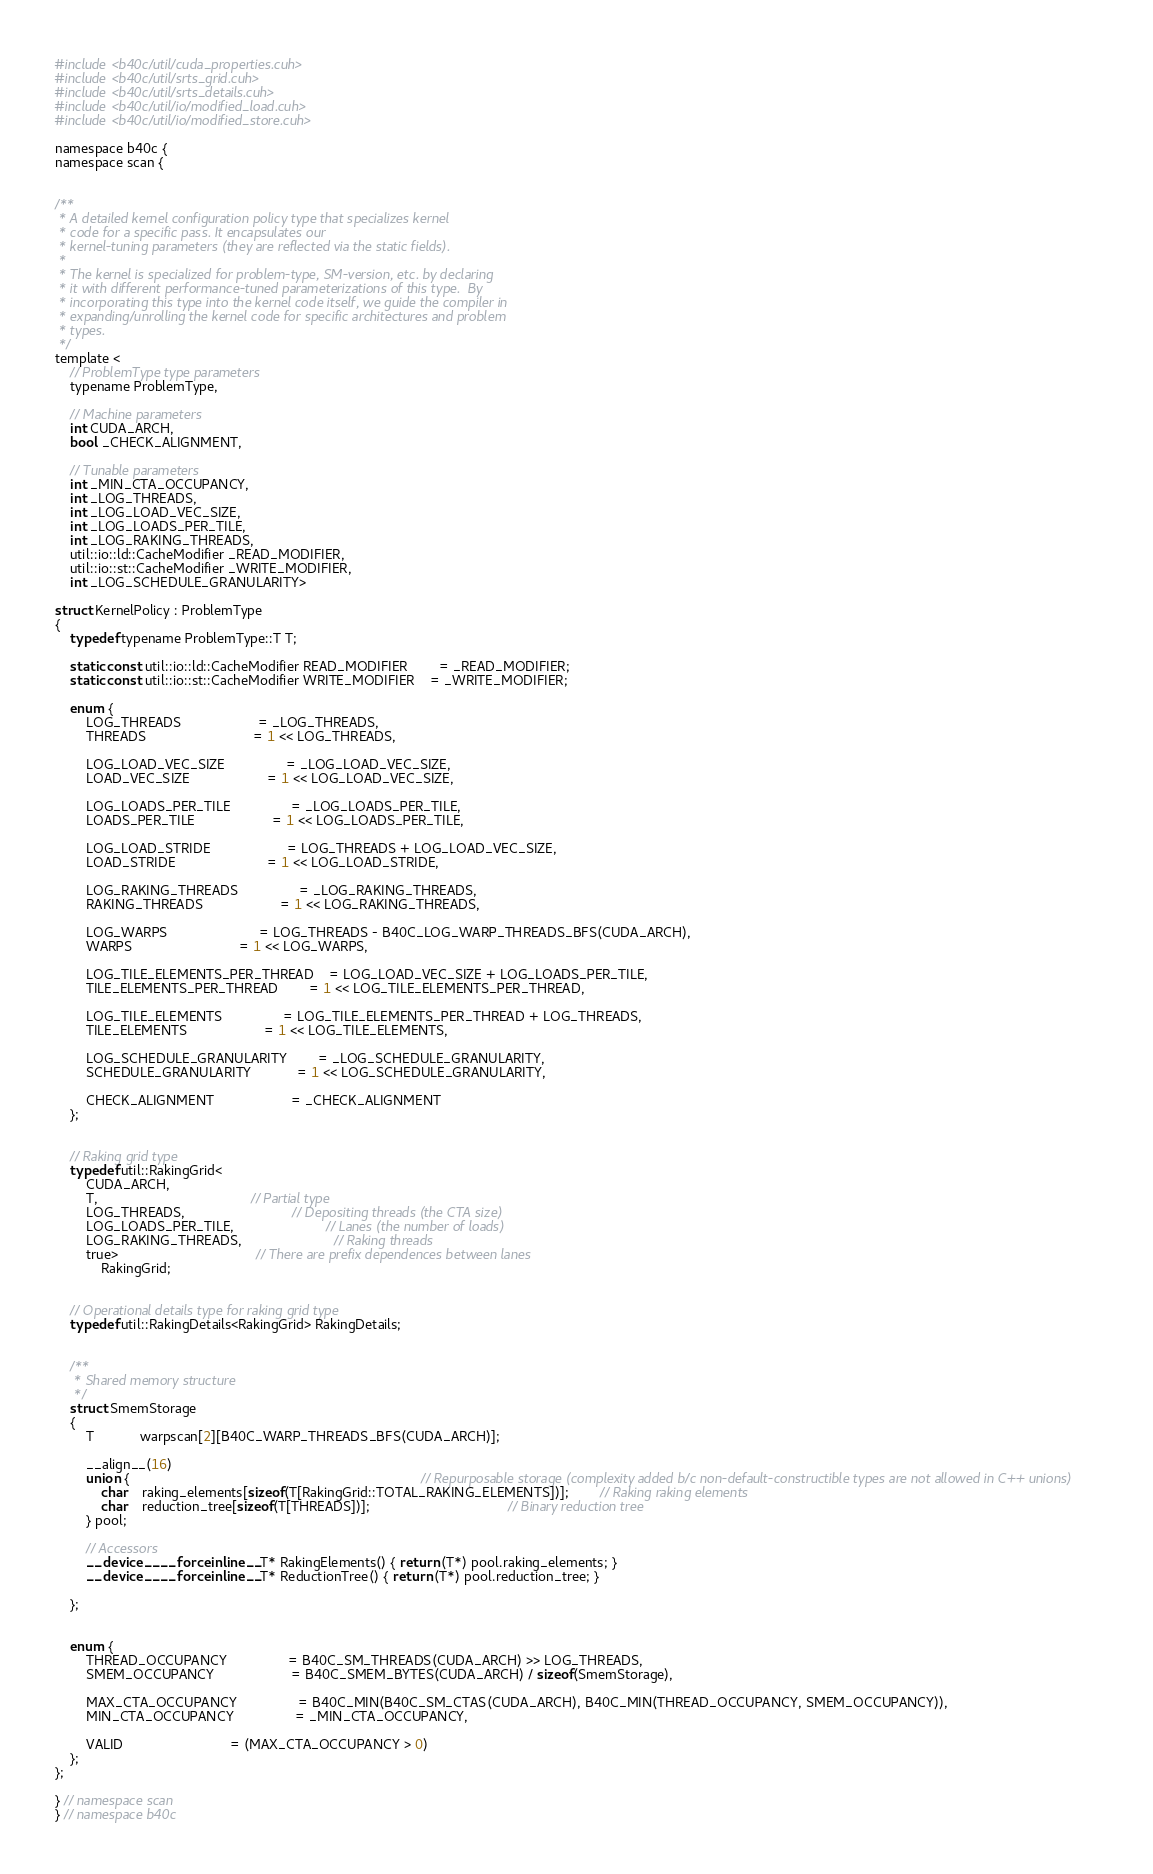<code> <loc_0><loc_0><loc_500><loc_500><_Cuda_>#include <b40c/util/cuda_properties.cuh>
#include <b40c/util/srts_grid.cuh>
#include <b40c/util/srts_details.cuh>
#include <b40c/util/io/modified_load.cuh>
#include <b40c/util/io/modified_store.cuh>

namespace b40c {
namespace scan {


/**
 * A detailed kernel configuration policy type that specializes kernel
 * code for a specific pass. It encapsulates our
 * kernel-tuning parameters (they are reflected via the static fields).
 *
 * The kernel is specialized for problem-type, SM-version, etc. by declaring
 * it with different performance-tuned parameterizations of this type.  By
 * incorporating this type into the kernel code itself, we guide the compiler in
 * expanding/unrolling the kernel code for specific architectures and problem
 * types.
 */
template <
	// ProblemType type parameters
	typename ProblemType,

	// Machine parameters
	int CUDA_ARCH,
	bool _CHECK_ALIGNMENT,

	// Tunable parameters
	int _MIN_CTA_OCCUPANCY,
	int _LOG_THREADS,
	int _LOG_LOAD_VEC_SIZE,
	int _LOG_LOADS_PER_TILE,
	int _LOG_RAKING_THREADS,
	util::io::ld::CacheModifier _READ_MODIFIER,
	util::io::st::CacheModifier _WRITE_MODIFIER,
	int _LOG_SCHEDULE_GRANULARITY>

struct KernelPolicy : ProblemType
{
	typedef typename ProblemType::T T;

	static const util::io::ld::CacheModifier READ_MODIFIER 		= _READ_MODIFIER;
	static const util::io::st::CacheModifier WRITE_MODIFIER 	= _WRITE_MODIFIER;

	enum {
		LOG_THREADS 					= _LOG_THREADS,
		THREADS							= 1 << LOG_THREADS,

		LOG_LOAD_VEC_SIZE  				= _LOG_LOAD_VEC_SIZE,
		LOAD_VEC_SIZE					= 1 << LOG_LOAD_VEC_SIZE,

		LOG_LOADS_PER_TILE 				= _LOG_LOADS_PER_TILE,
		LOADS_PER_TILE					= 1 << LOG_LOADS_PER_TILE,

		LOG_LOAD_STRIDE					= LOG_THREADS + LOG_LOAD_VEC_SIZE,
		LOAD_STRIDE						= 1 << LOG_LOAD_STRIDE,

		LOG_RAKING_THREADS				= _LOG_RAKING_THREADS,
		RAKING_THREADS					= 1 << LOG_RAKING_THREADS,

		LOG_WARPS						= LOG_THREADS - B40C_LOG_WARP_THREADS_BFS(CUDA_ARCH),
		WARPS							= 1 << LOG_WARPS,

		LOG_TILE_ELEMENTS_PER_THREAD	= LOG_LOAD_VEC_SIZE + LOG_LOADS_PER_TILE,
		TILE_ELEMENTS_PER_THREAD		= 1 << LOG_TILE_ELEMENTS_PER_THREAD,

		LOG_TILE_ELEMENTS 				= LOG_TILE_ELEMENTS_PER_THREAD + LOG_THREADS,
		TILE_ELEMENTS					= 1 << LOG_TILE_ELEMENTS,

		LOG_SCHEDULE_GRANULARITY		= _LOG_SCHEDULE_GRANULARITY,
		SCHEDULE_GRANULARITY			= 1 << LOG_SCHEDULE_GRANULARITY,

		CHECK_ALIGNMENT					= _CHECK_ALIGNMENT
	};


	// Raking grid type
	typedef util::RakingGrid<
		CUDA_ARCH,
		T,										// Partial type
		LOG_THREADS,							// Depositing threads (the CTA size)
		LOG_LOADS_PER_TILE,						// Lanes (the number of loads)
		LOG_RAKING_THREADS,						// Raking threads
		true>									// There are prefix dependences between lanes
			RakingGrid;


	// Operational details type for raking grid type
	typedef util::RakingDetails<RakingGrid> RakingDetails;


	/**
	 * Shared memory structure
	 */
	struct SmemStorage
	{
		T 			warpscan[2][B40C_WARP_THREADS_BFS(CUDA_ARCH)];

		__align__(16)
		union {																			// Repurposable storage (complexity added b/c non-default-constructible types are not allowed in C++ unions)
			char	raking_elements[sizeof(T[RakingGrid::TOTAL_RAKING_ELEMENTS])];		// Raking raking elements
			char	reduction_tree[sizeof(T[THREADS])];									// Binary reduction tree
		} pool;

		// Accessors
		__device__ __forceinline__ T* RakingElements() { return (T*) pool.raking_elements; }
		__device__ __forceinline__ T* ReductionTree() { return (T*) pool.reduction_tree; }

	};


	enum {
		THREAD_OCCUPANCY				= B40C_SM_THREADS(CUDA_ARCH) >> LOG_THREADS,
		SMEM_OCCUPANCY					= B40C_SMEM_BYTES(CUDA_ARCH) / sizeof(SmemStorage),

		MAX_CTA_OCCUPANCY  				= B40C_MIN(B40C_SM_CTAS(CUDA_ARCH), B40C_MIN(THREAD_OCCUPANCY, SMEM_OCCUPANCY)),
		MIN_CTA_OCCUPANCY 				= _MIN_CTA_OCCUPANCY,

		VALID							= (MAX_CTA_OCCUPANCY > 0)
	};
};

} // namespace scan
} // namespace b40c

</code> 